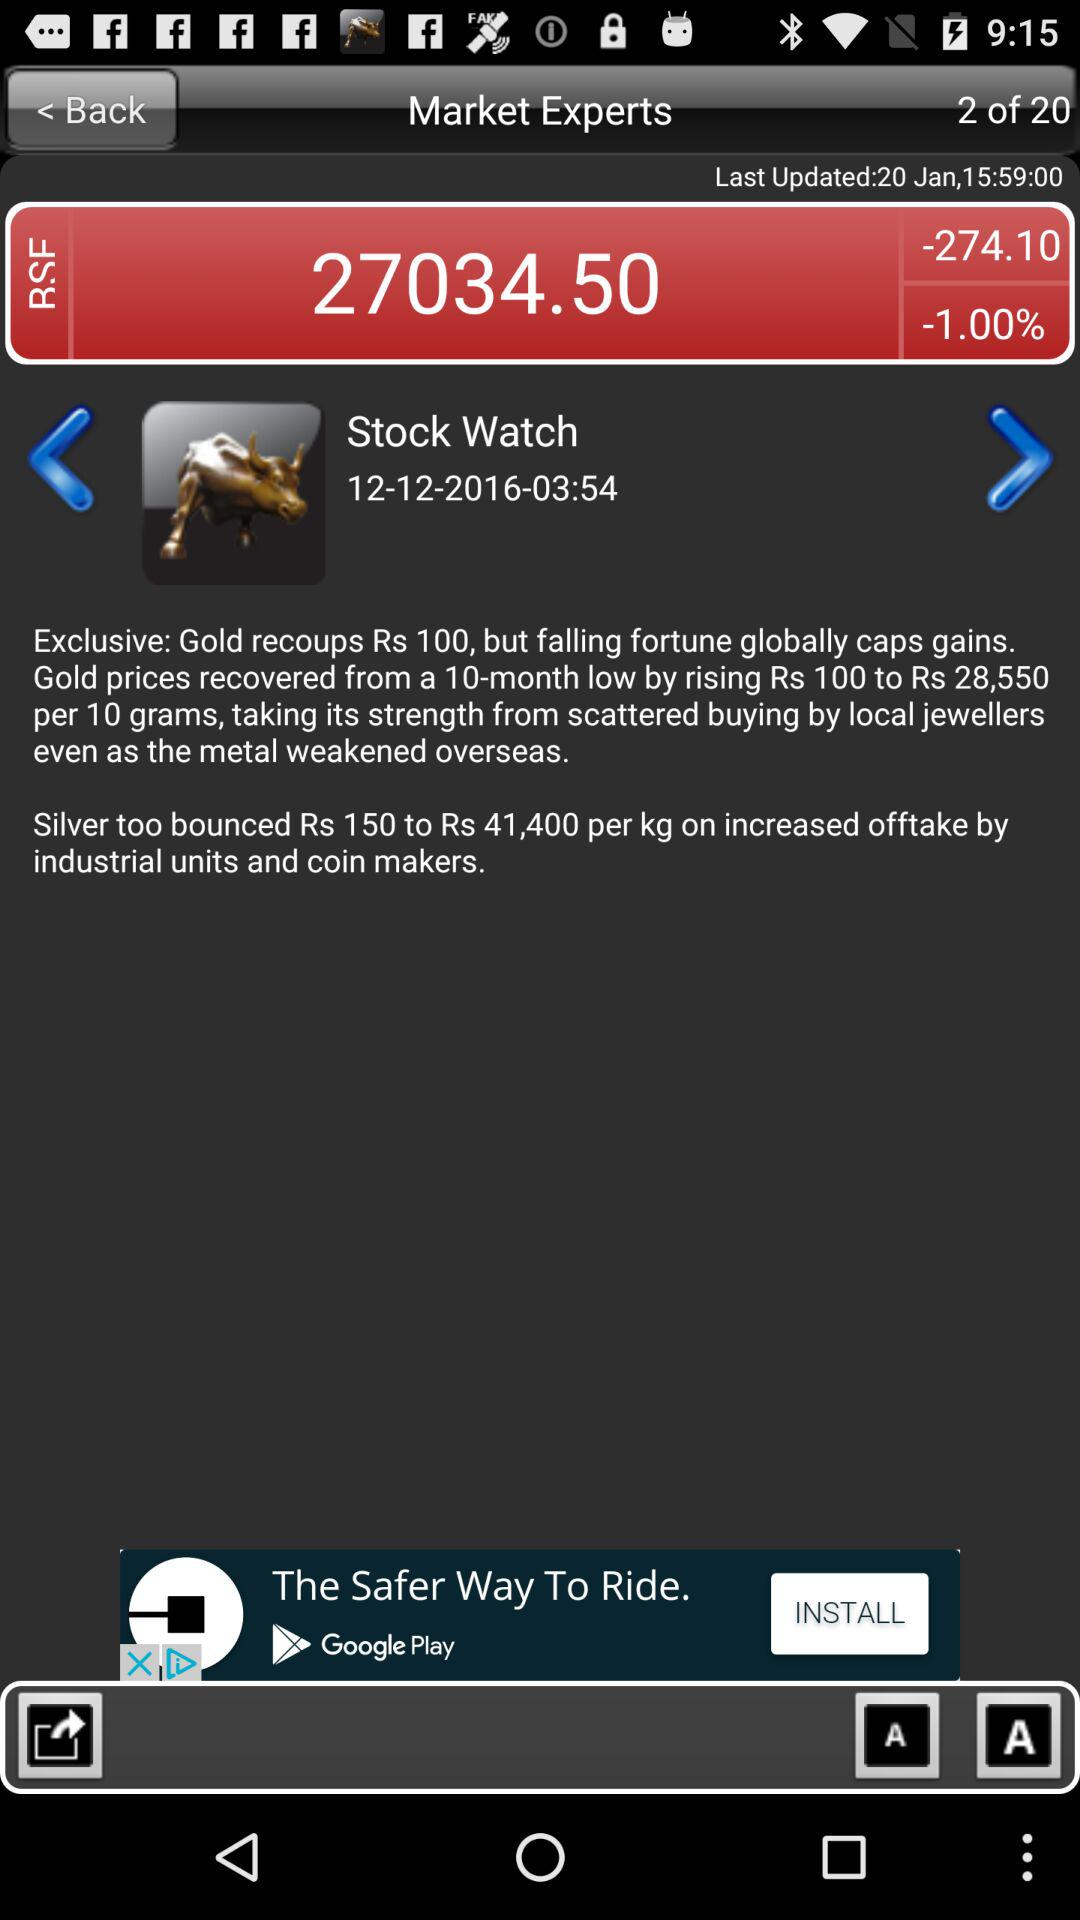What is the date of "Stock Watch"? The date of "Stock Watch" is December 12, 2016. 